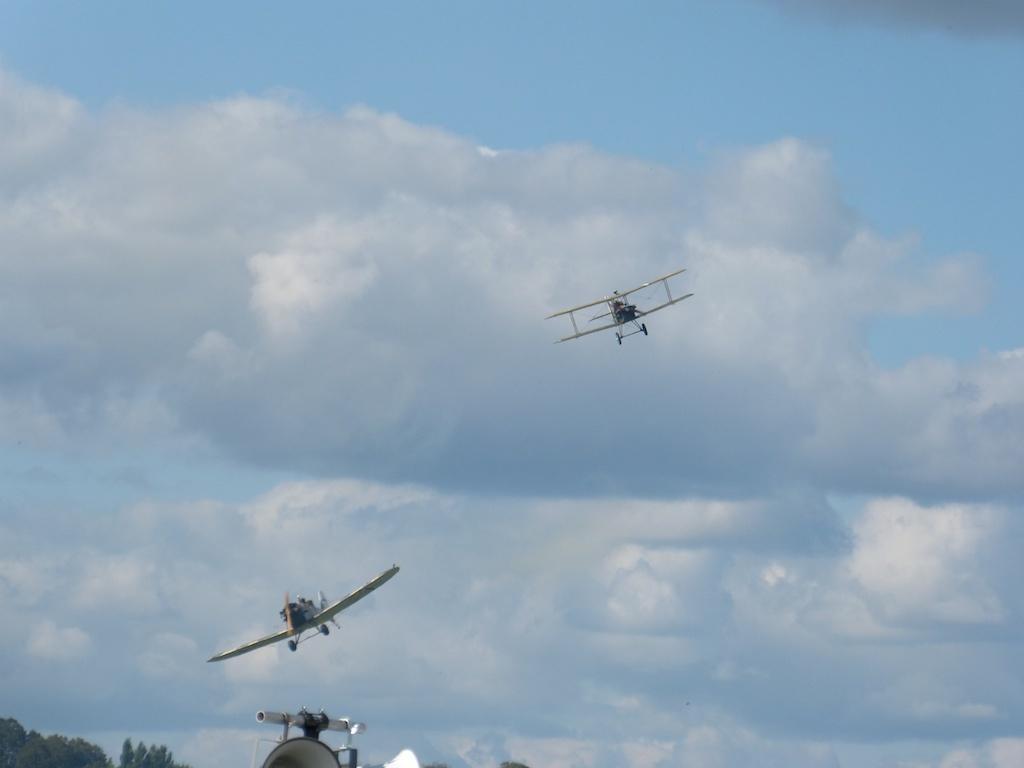Could you give a brief overview of what you see in this image? In this image we can see airplanes flying in the sky and in the bottom there are trees and an object. 